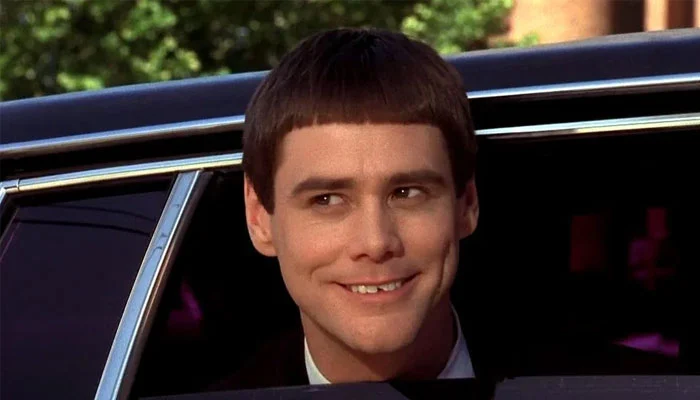What might be the mood or atmosphere suggested by the setting and the subject's expression in this image? The mood in this image is lively and jovial. The subject's broad smile and the sparkling eyes contribute to a sense of happiness and amusement. Additionally, the motion blur in the background could suggest an exciting or dynamic atmosphere, perhaps of a pleasant journey or a fun outing. 